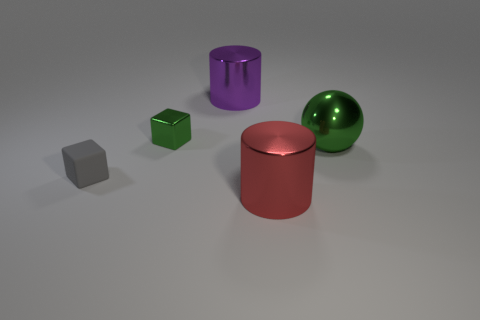Add 3 tiny gray matte cylinders. How many objects exist? 8 Subtract all cubes. How many objects are left? 3 Add 3 large cylinders. How many large cylinders are left? 5 Add 3 red shiny cylinders. How many red shiny cylinders exist? 4 Subtract 1 green cubes. How many objects are left? 4 Subtract all small red rubber cylinders. Subtract all purple metal things. How many objects are left? 4 